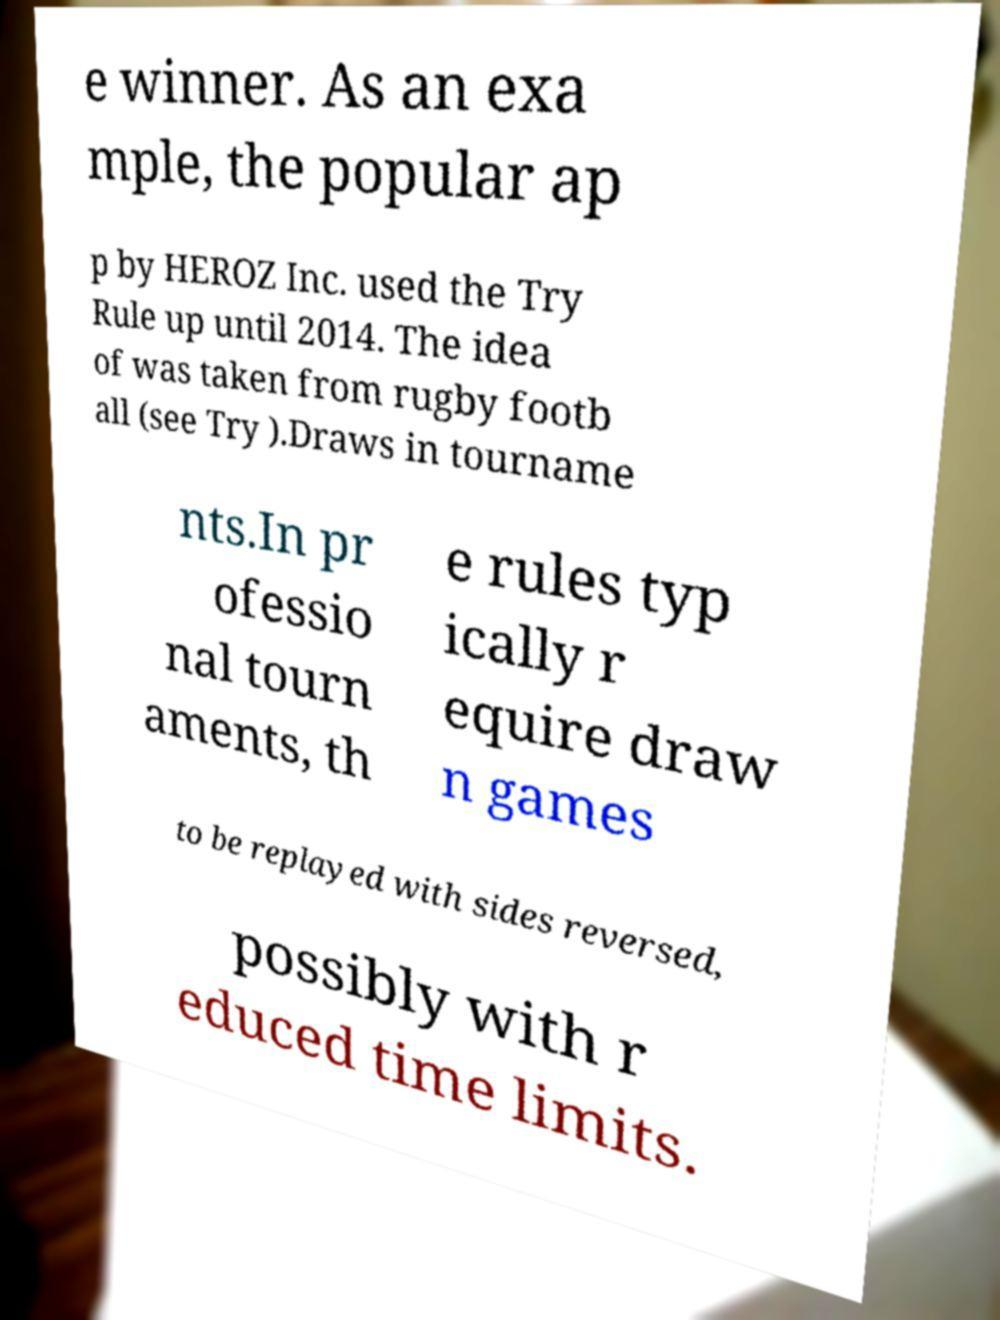Can you accurately transcribe the text from the provided image for me? e winner. As an exa mple, the popular ap p by HEROZ Inc. used the Try Rule up until 2014. The idea of was taken from rugby footb all (see Try ).Draws in tourname nts.In pr ofessio nal tourn aments, th e rules typ ically r equire draw n games to be replayed with sides reversed, possibly with r educed time limits. 